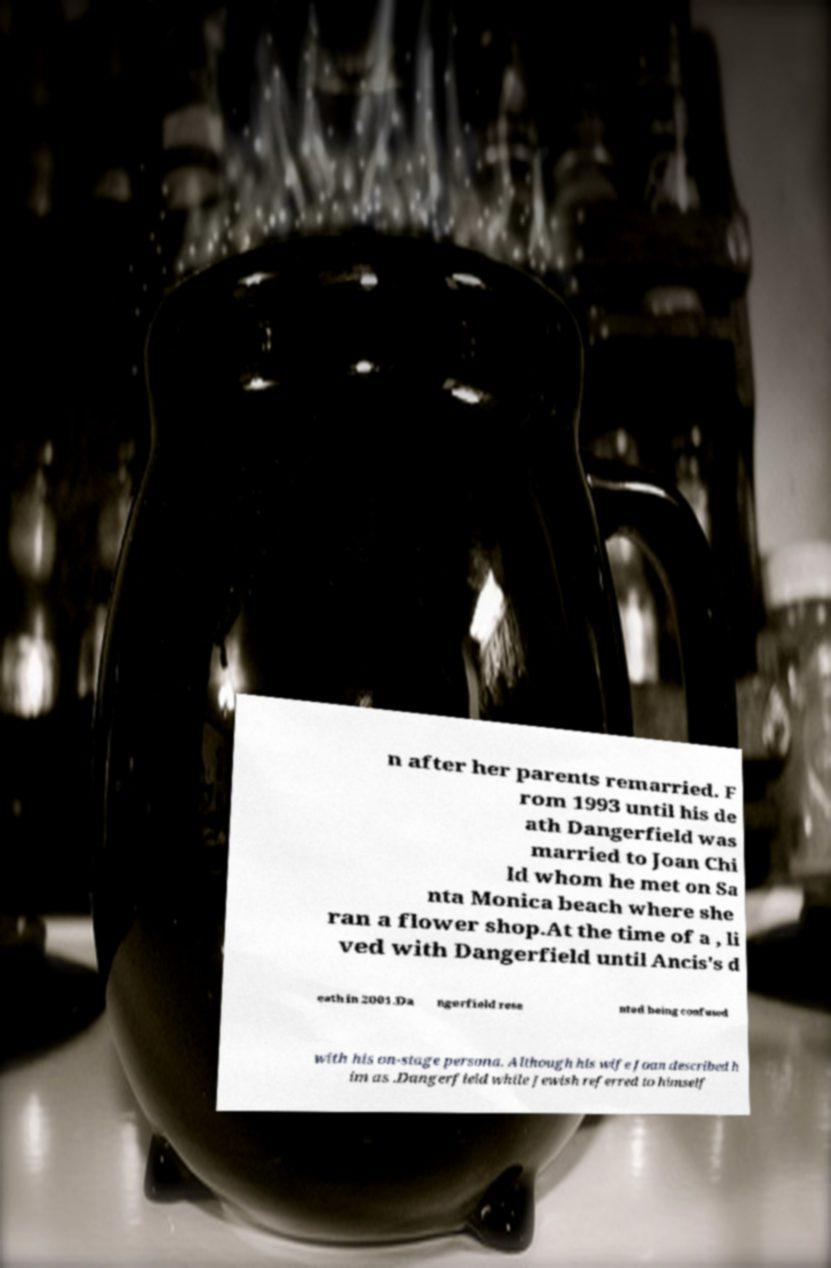Could you extract and type out the text from this image? n after her parents remarried. F rom 1993 until his de ath Dangerfield was married to Joan Chi ld whom he met on Sa nta Monica beach where she ran a flower shop.At the time of a , li ved with Dangerfield until Ancis's d eath in 2001.Da ngerfield rese nted being confused with his on-stage persona. Although his wife Joan described h im as .Dangerfield while Jewish referred to himself 